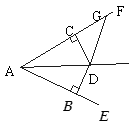First perform reasoning, then finally select the question from the choices in the following format: Answer: xxx.
Question: As shown in the figure, it is known that DB perpendicular  AE at B, DC perpendicular  AF at C, and DB = DC, angle BAC = 40.0, angle ADG = 130.0, then angle DGF = ()
Choices:
A: 130°
B: 150°
C: 100°
D: 140° Since DB is perpendicular to AE and DC is perpendicular to AF, and DB is equal to DC, we have angle GAD = angle BAD = 1/2 angle BAC = 20°. Therefore, angle DGF = angle GAD + angle ADG = 20° + 130° = 150°. So the answer is B.
Answer:B 